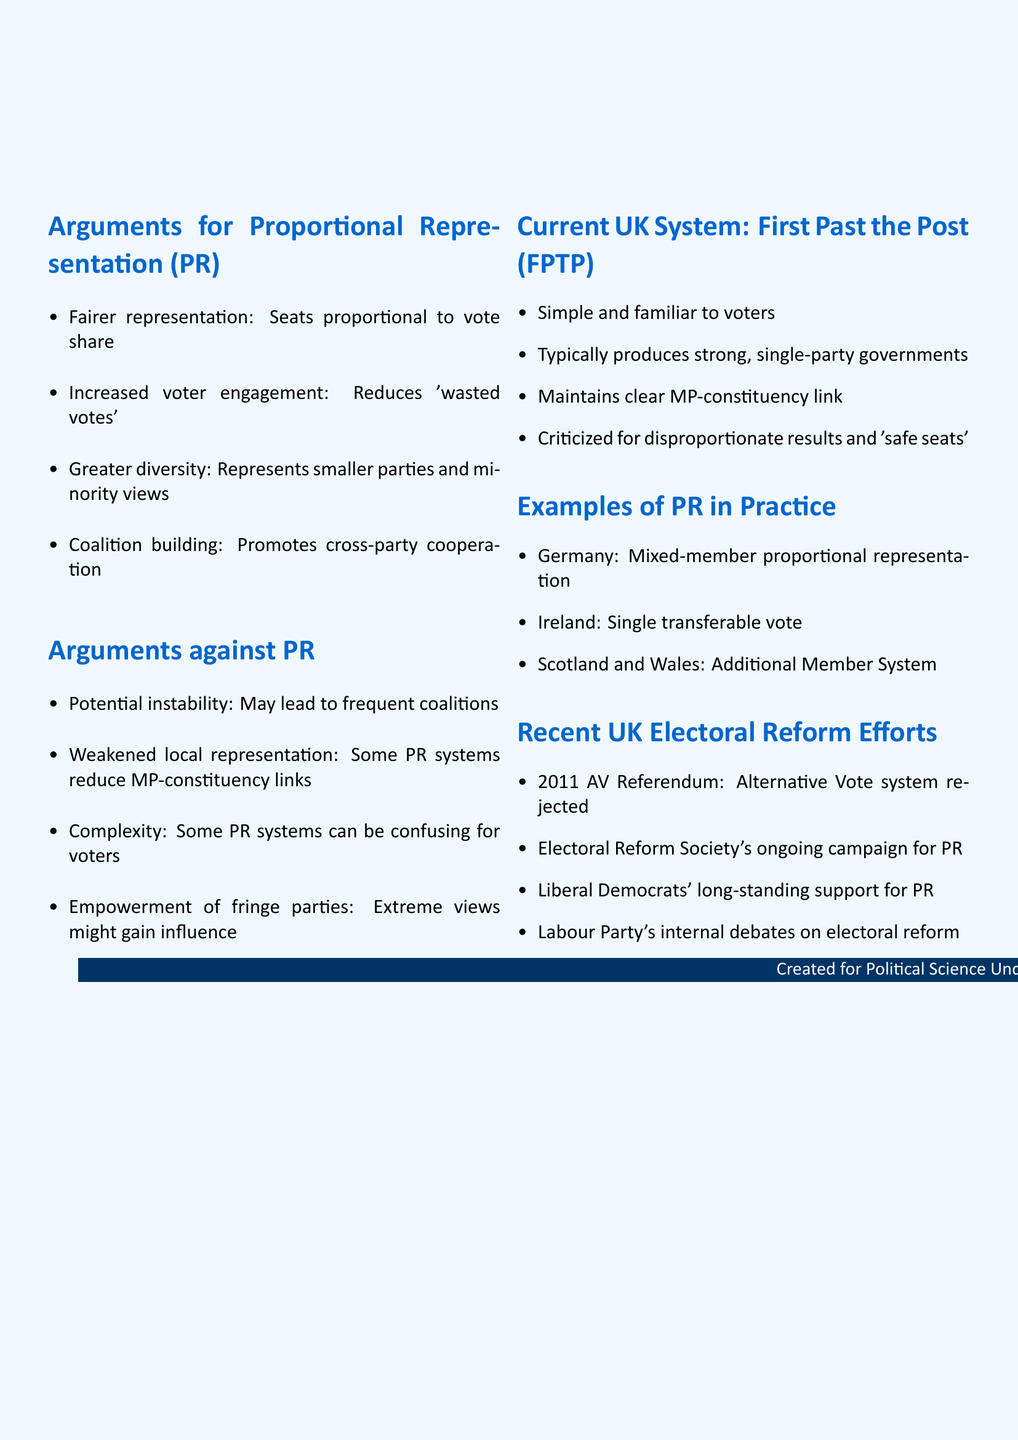What does PR ensure? PR ensures that parties receive seats proportional to their vote share.
Answer: Fairer representation What was the outcome of the 2011 AV Referendum? The 2011 AV Referendum proposed an Alternative Vote system, which was rejected by voters.
Answer: Rejected by voters Name a system used for PR in Germany. In Germany, the Mixed-member proportional representation system is used.
Answer: Mixed-member proportional representation What is a potential downside of PR? One potential downside of PR is that it may lead to frequent coalition governments.
Answer: Potential instability Which UK political party has a long-standing support for PR? The Liberal Democrats have a long-standing support for PR.
Answer: Liberal Democrats What type of government does FPTP typically produce? FPTP typically produces strong, single-party governments.
Answer: Strong, single-party governments What issue does the current UK electoral system face, according to the document? The current UK electoral system is criticized for producing disproportionate results and 'safe seats'.
Answer: Disproportionate results and 'safe seats' What is one argument for increased voter engagement? Increased voter engagement is argued to reduce 'wasted votes' in safe seats.
Answer: Reduces 'wasted votes' Which system is used in Ireland for PR? Ireland uses the Single transferable vote system for PR.
Answer: Single transferable vote 